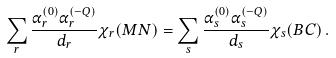<formula> <loc_0><loc_0><loc_500><loc_500>\sum _ { r } \frac { \alpha _ { r } ^ { ( 0 ) } \alpha _ { r } ^ { ( - Q ) } } { d _ { r } } \chi _ { r } ( M N ) = \sum _ { s } \frac { \alpha _ { s } ^ { ( 0 ) } \alpha _ { s } ^ { ( - Q ) } } { d _ { s } } \chi _ { s } ( B C ) \, .</formula> 